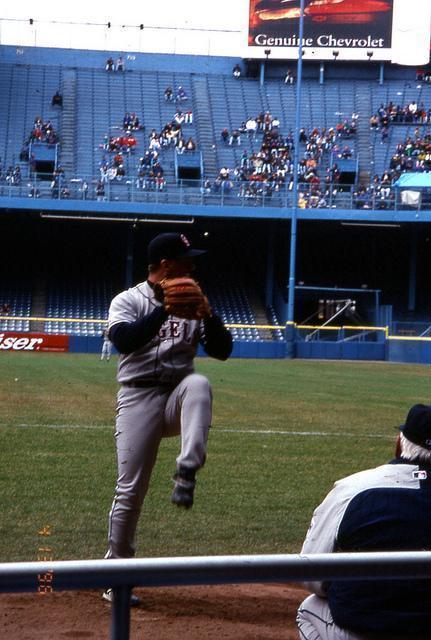What is the nickname of the motor vehicle company advertised?
From the following four choices, select the correct answer to address the question.
Options: Prius, chevy, hummer, beamer. Chevy. 